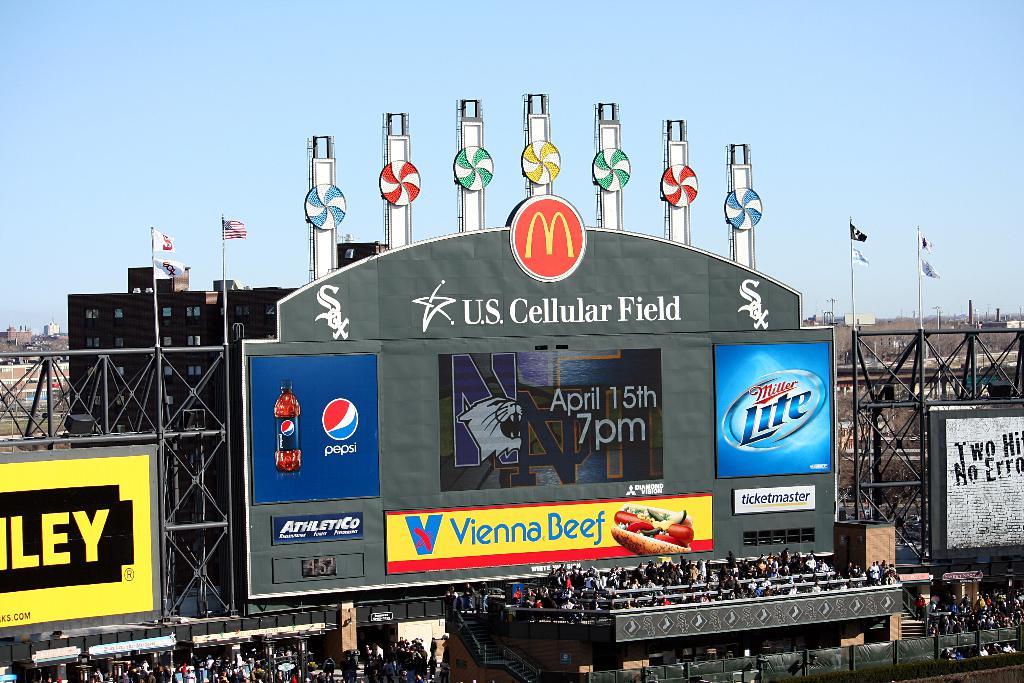What baseball stadium is this?
Your answer should be very brief. U.s. cellular field. 